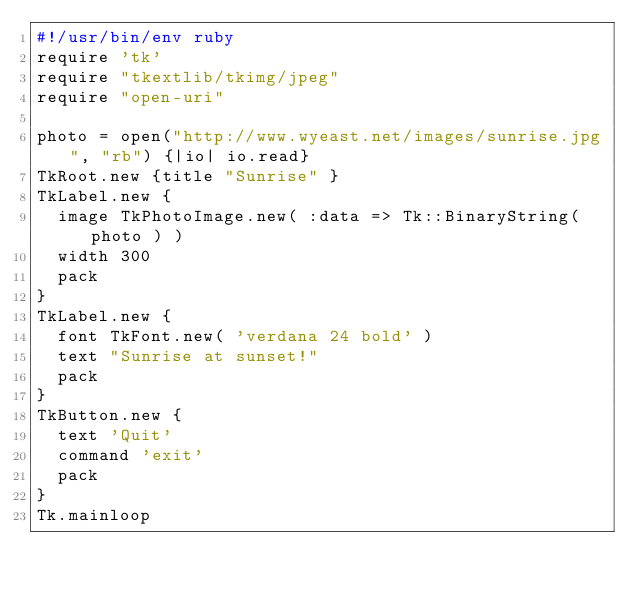<code> <loc_0><loc_0><loc_500><loc_500><_Ruby_>#!/usr/bin/env ruby
require 'tk'
require "tkextlib/tkimg/jpeg"
require "open-uri"

photo = open("http://www.wyeast.net/images/sunrise.jpg", "rb") {|io| io.read}
TkRoot.new {title "Sunrise" }
TkLabel.new {
  image TkPhotoImage.new( :data => Tk::BinaryString( photo ) )
  width 300
  pack
}
TkLabel.new {
  font TkFont.new( 'verdana 24 bold' )
  text "Sunrise at sunset!"
  pack
}
TkButton.new {
  text 'Quit'
  command 'exit'
  pack
}
Tk.mainloop
</code> 